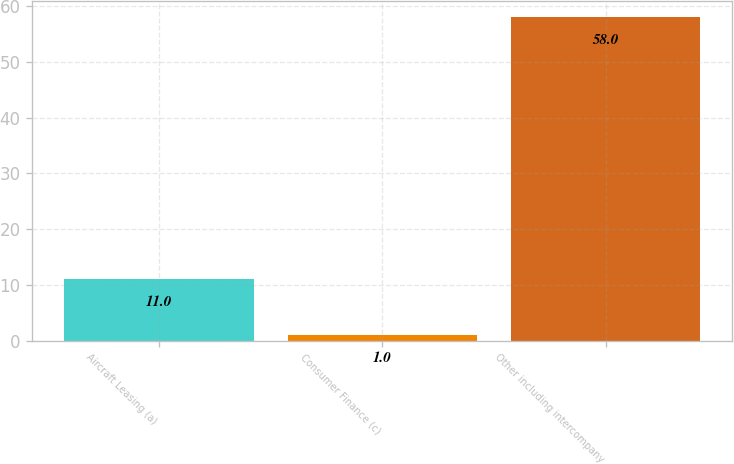Convert chart. <chart><loc_0><loc_0><loc_500><loc_500><bar_chart><fcel>Aircraft Leasing (a)<fcel>Consumer Finance (c)<fcel>Other including intercompany<nl><fcel>11<fcel>1<fcel>58<nl></chart> 